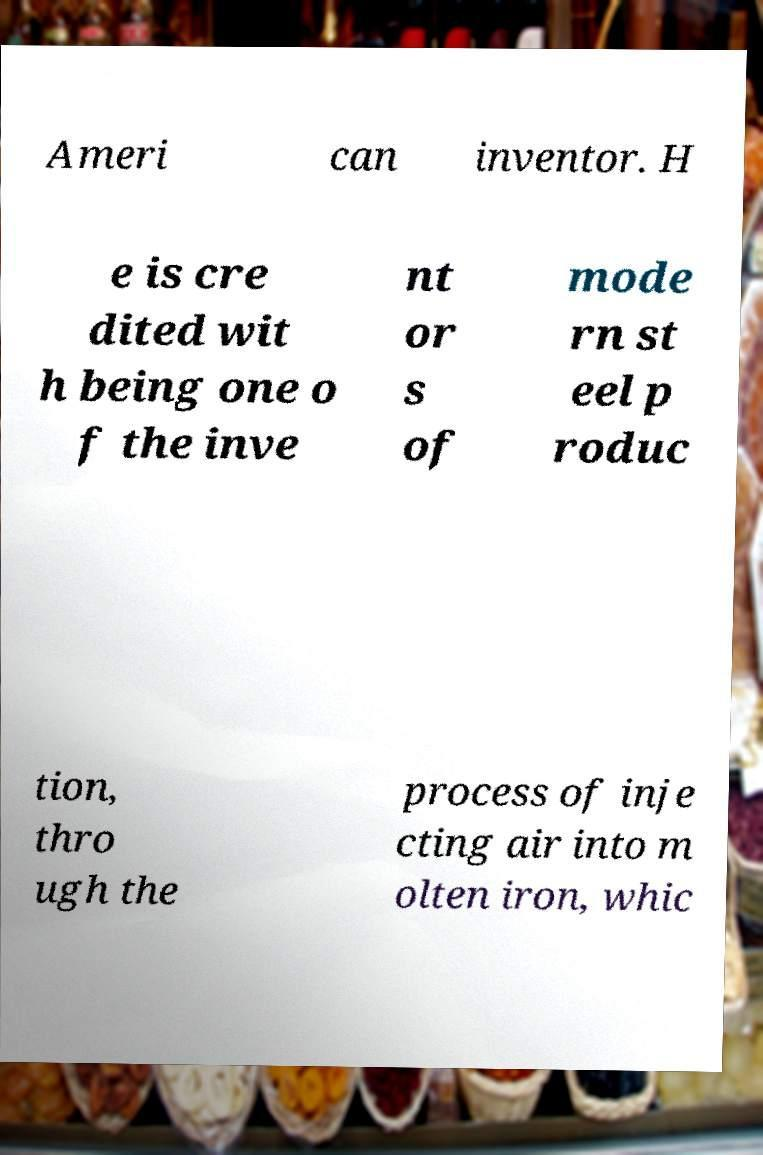I need the written content from this picture converted into text. Can you do that? Ameri can inventor. H e is cre dited wit h being one o f the inve nt or s of mode rn st eel p roduc tion, thro ugh the process of inje cting air into m olten iron, whic 